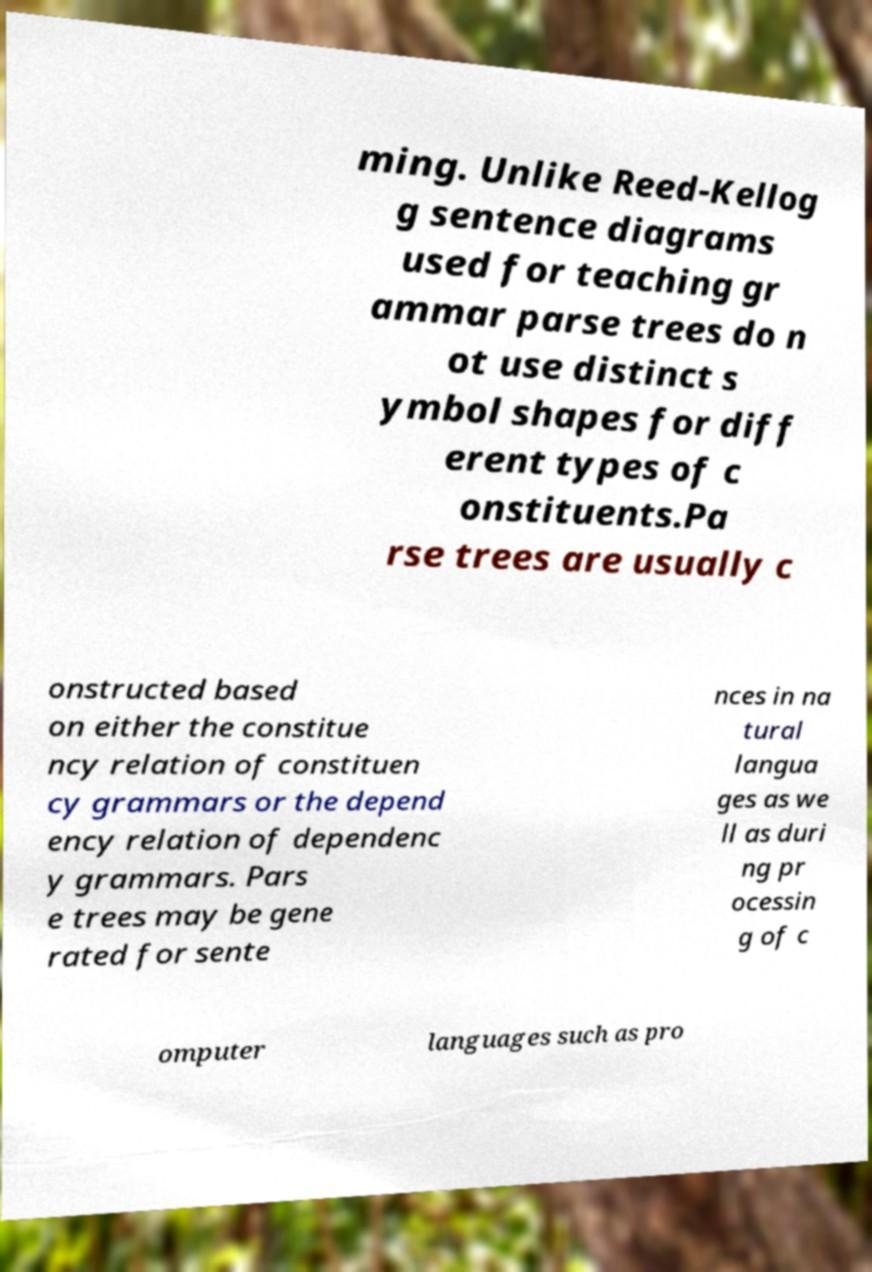Could you assist in decoding the text presented in this image and type it out clearly? ming. Unlike Reed-Kellog g sentence diagrams used for teaching gr ammar parse trees do n ot use distinct s ymbol shapes for diff erent types of c onstituents.Pa rse trees are usually c onstructed based on either the constitue ncy relation of constituen cy grammars or the depend ency relation of dependenc y grammars. Pars e trees may be gene rated for sente nces in na tural langua ges as we ll as duri ng pr ocessin g of c omputer languages such as pro 